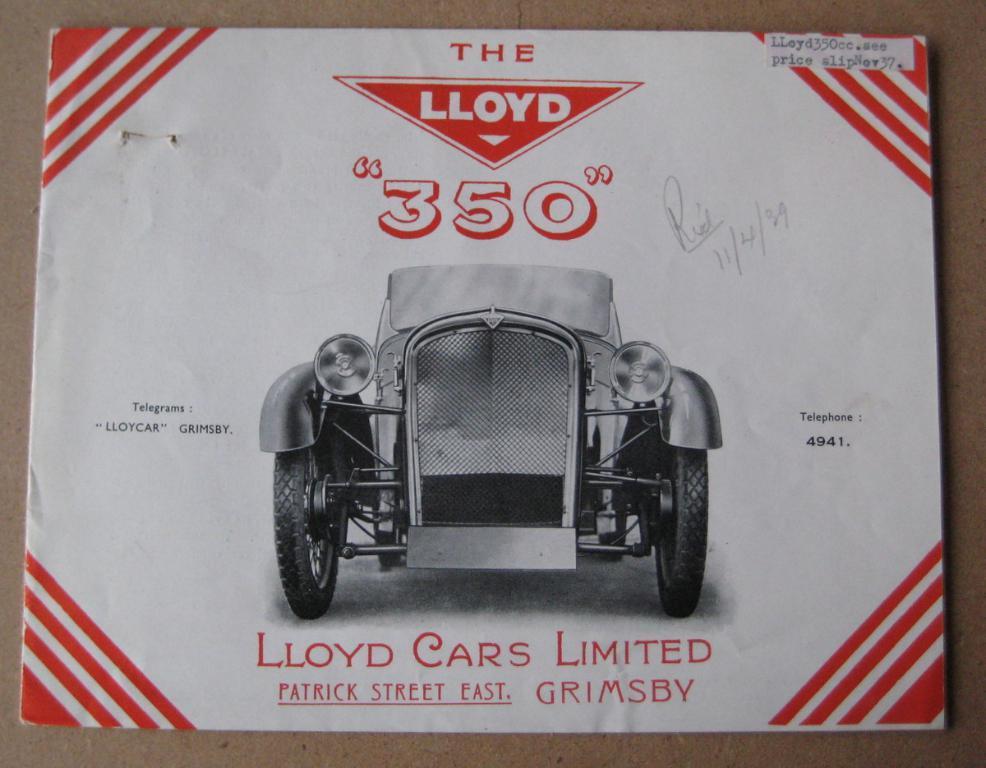How would you summarize this image in a sentence or two? In this picture there is a book which is kept on the table. In that I can see the car. 